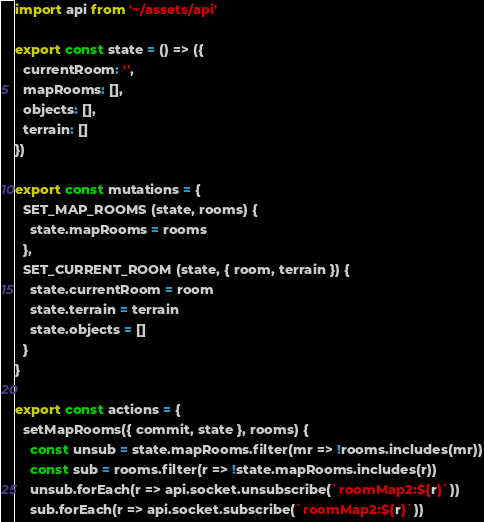<code> <loc_0><loc_0><loc_500><loc_500><_JavaScript_>import api from '~/assets/api'

export const state = () => ({
  currentRoom: '',
  mapRooms: [],
  objects: [],
  terrain: []
})

export const mutations = {
  SET_MAP_ROOMS (state, rooms) {
    state.mapRooms = rooms
  },
  SET_CURRENT_ROOM (state, { room, terrain }) {
    state.currentRoom = room
    state.terrain = terrain
    state.objects = []
  }
}

export const actions = {
  setMapRooms({ commit, state }, rooms) {
    const unsub = state.mapRooms.filter(mr => !rooms.includes(mr))
    const sub = rooms.filter(r => !state.mapRooms.includes(r))
    unsub.forEach(r => api.socket.unsubscribe(`roomMap2:${r}`))
    sub.forEach(r => api.socket.subscribe(`roomMap2:${r}`))</code> 